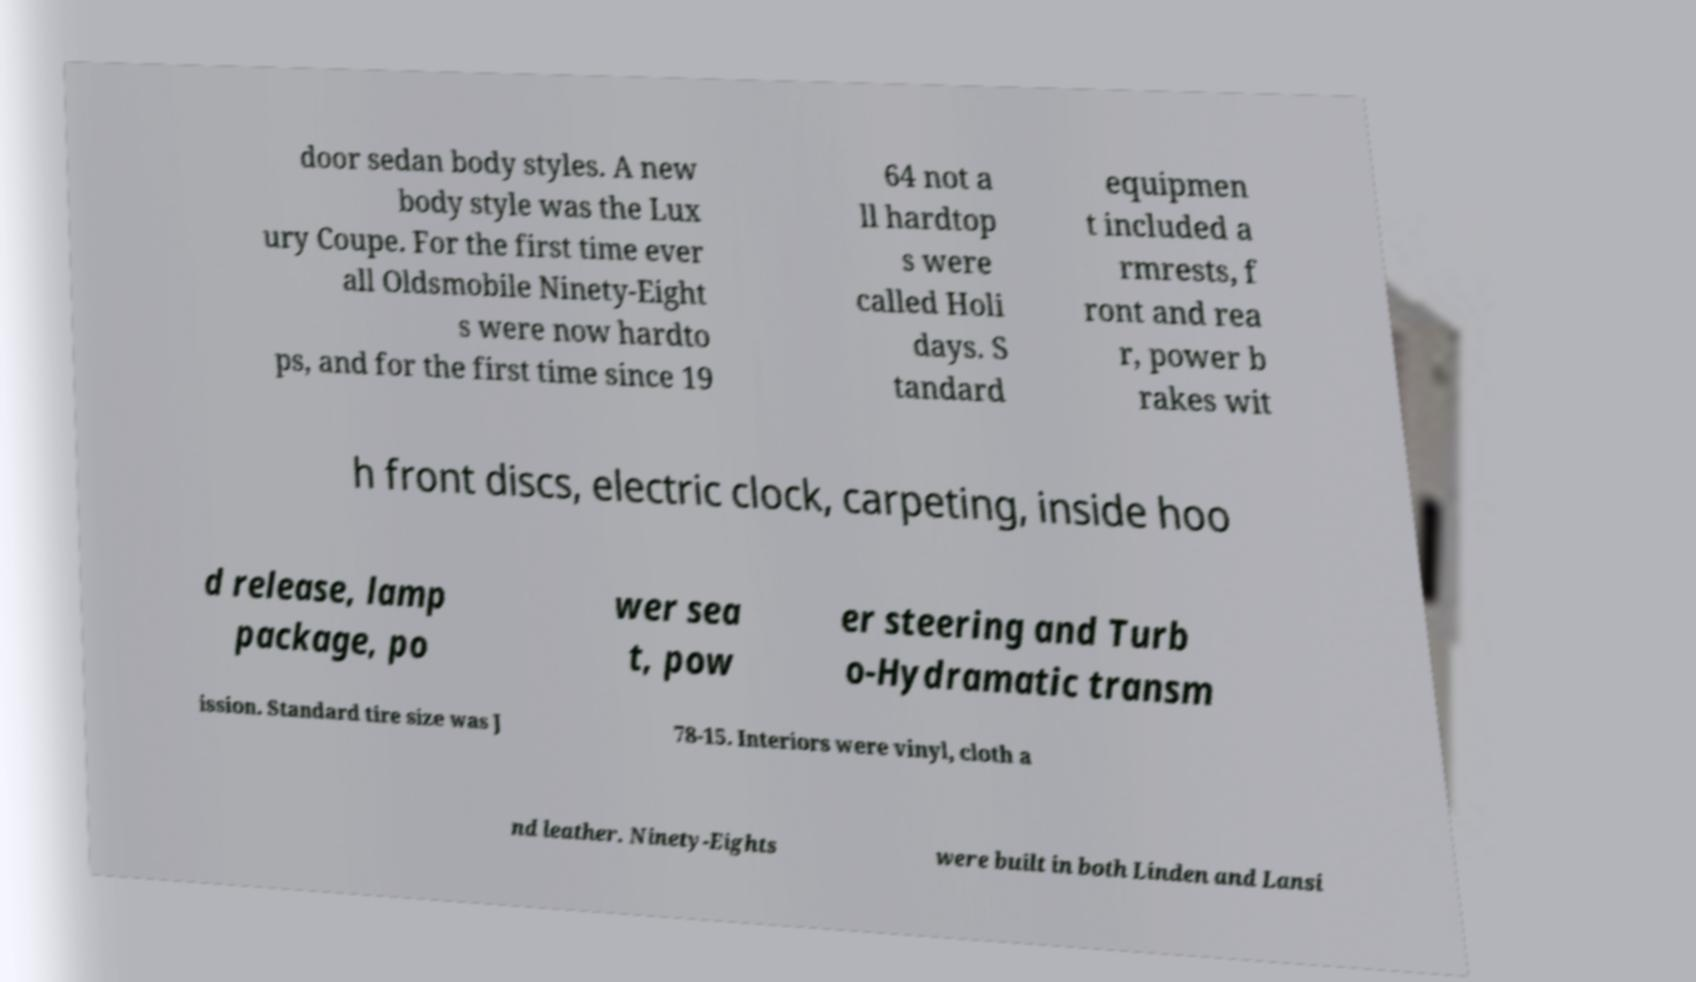There's text embedded in this image that I need extracted. Can you transcribe it verbatim? door sedan body styles. A new body style was the Lux ury Coupe. For the first time ever all Oldsmobile Ninety-Eight s were now hardto ps, and for the first time since 19 64 not a ll hardtop s were called Holi days. S tandard equipmen t included a rmrests, f ront and rea r, power b rakes wit h front discs, electric clock, carpeting, inside hoo d release, lamp package, po wer sea t, pow er steering and Turb o-Hydramatic transm ission. Standard tire size was J 78-15. Interiors were vinyl, cloth a nd leather. Ninety-Eights were built in both Linden and Lansi 